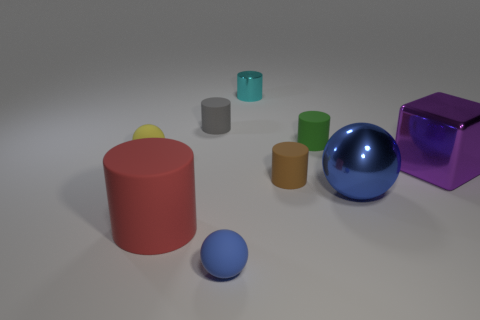Subtract all red cylinders. How many cylinders are left? 4 Subtract all yellow cylinders. Subtract all yellow spheres. How many cylinders are left? 5 Add 1 gray cylinders. How many objects exist? 10 Subtract all balls. How many objects are left? 6 Add 5 tiny purple cylinders. How many tiny purple cylinders exist? 5 Subtract 0 red spheres. How many objects are left? 9 Subtract all large purple rubber cylinders. Subtract all tiny gray cylinders. How many objects are left? 8 Add 7 brown cylinders. How many brown cylinders are left? 8 